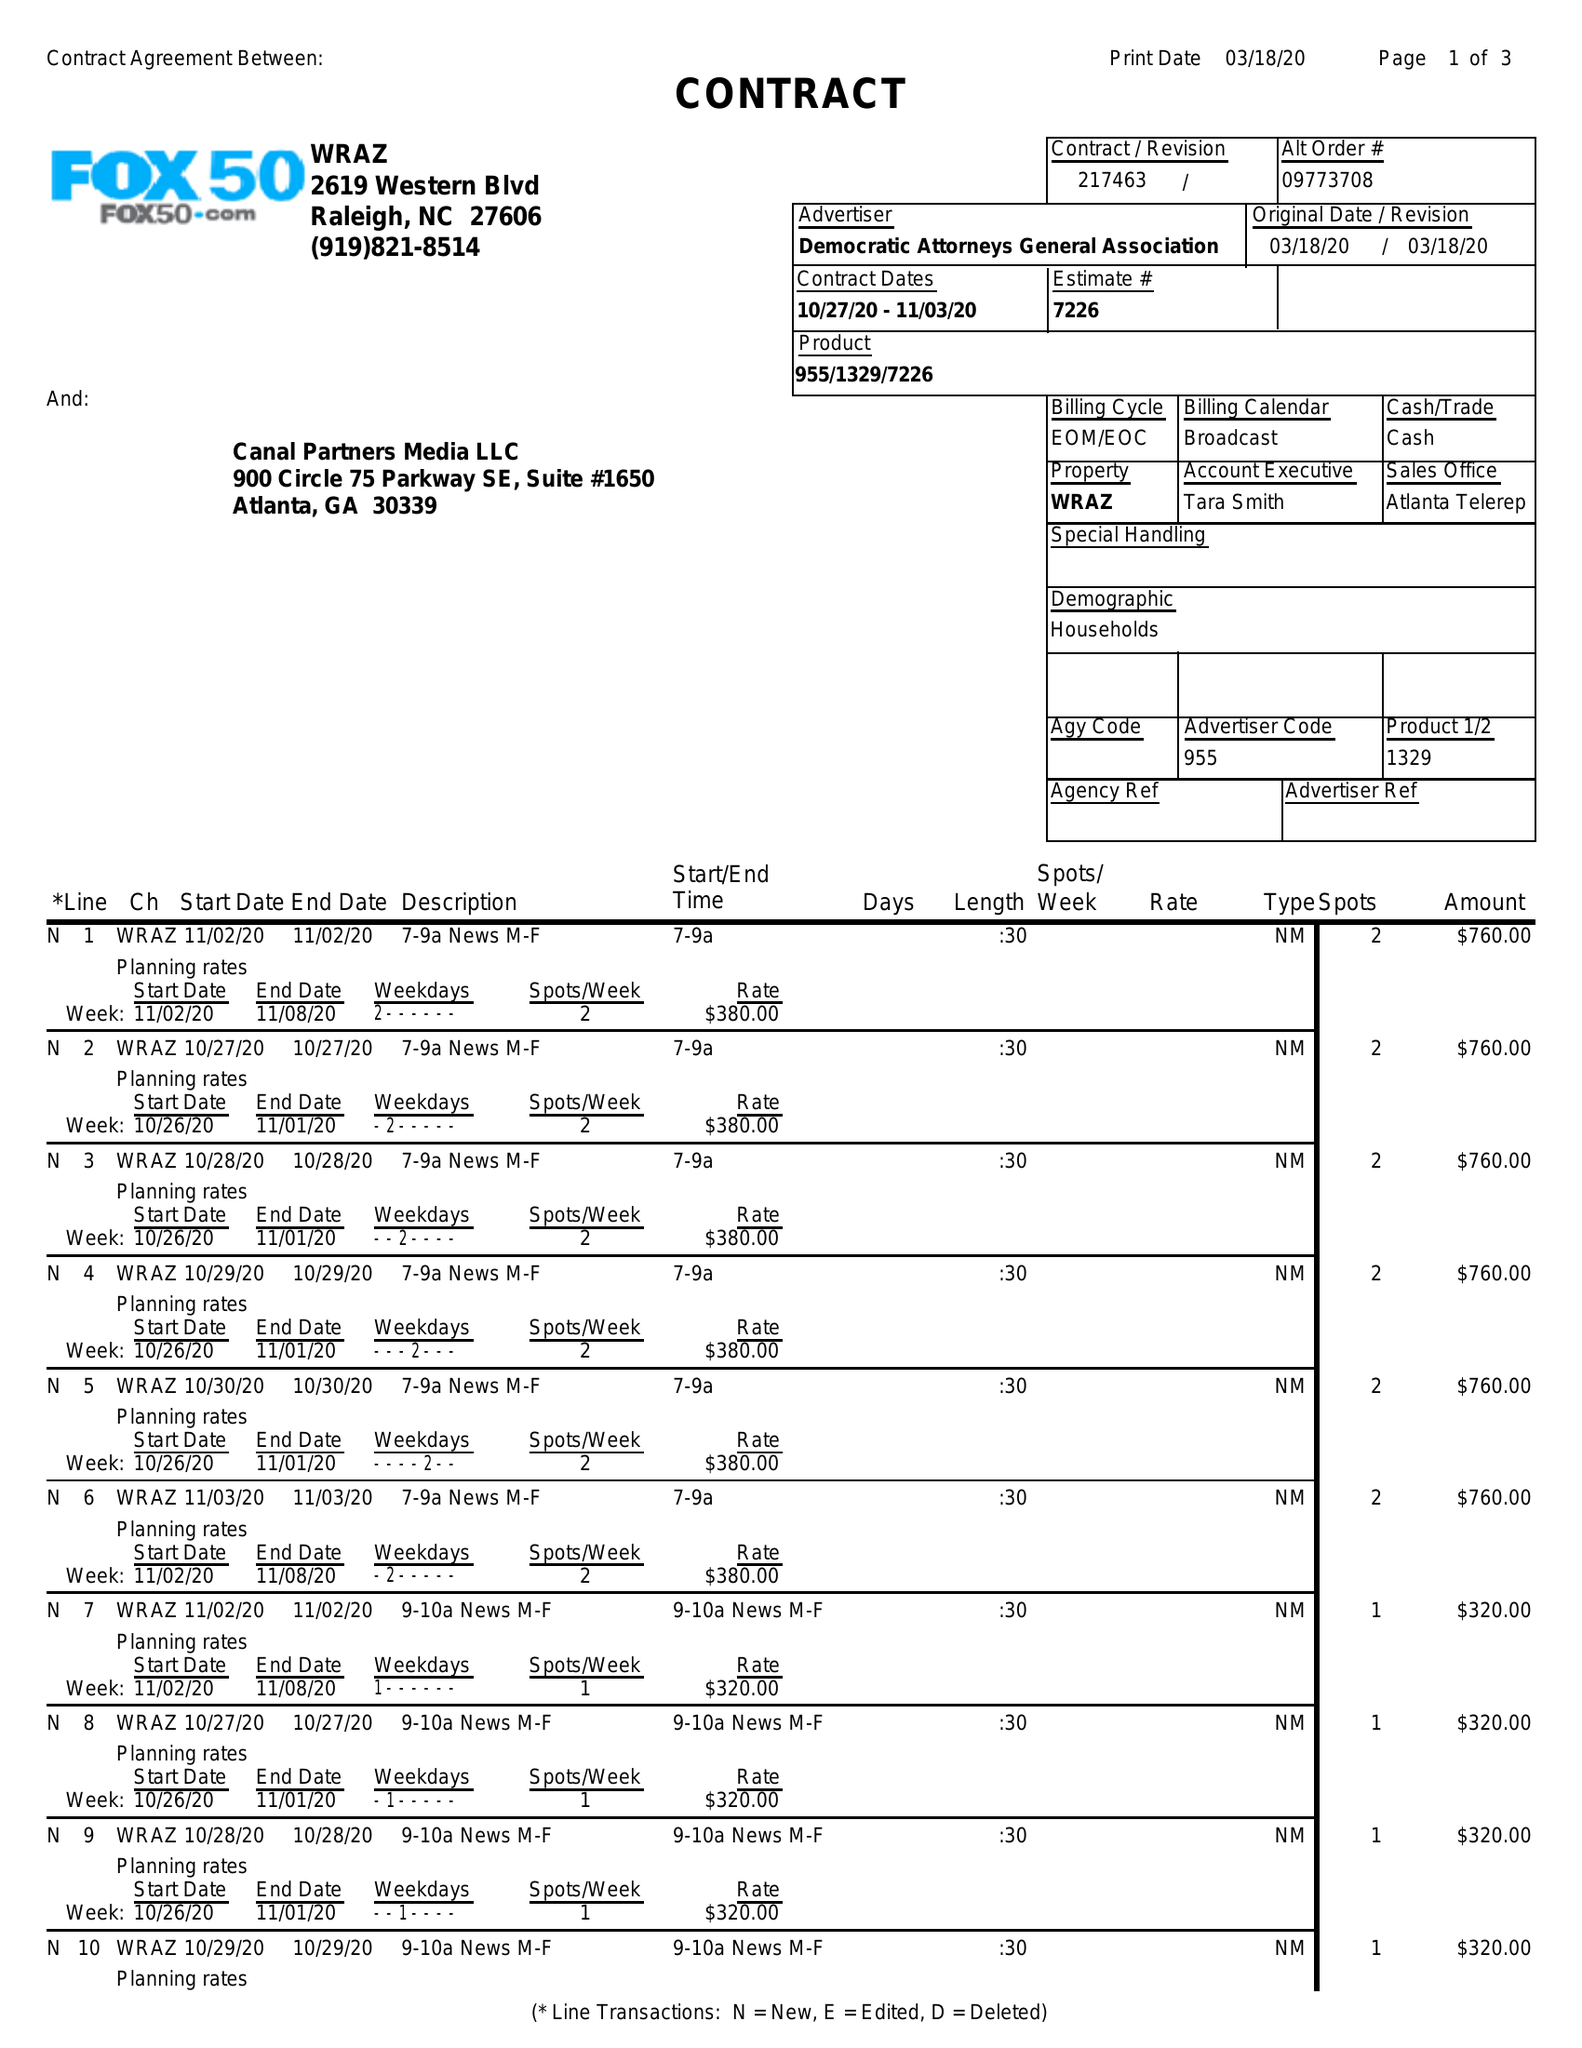What is the value for the advertiser?
Answer the question using a single word or phrase. DEMOCRATIC ATTORNEYS GENERAL ASSOCIATION 